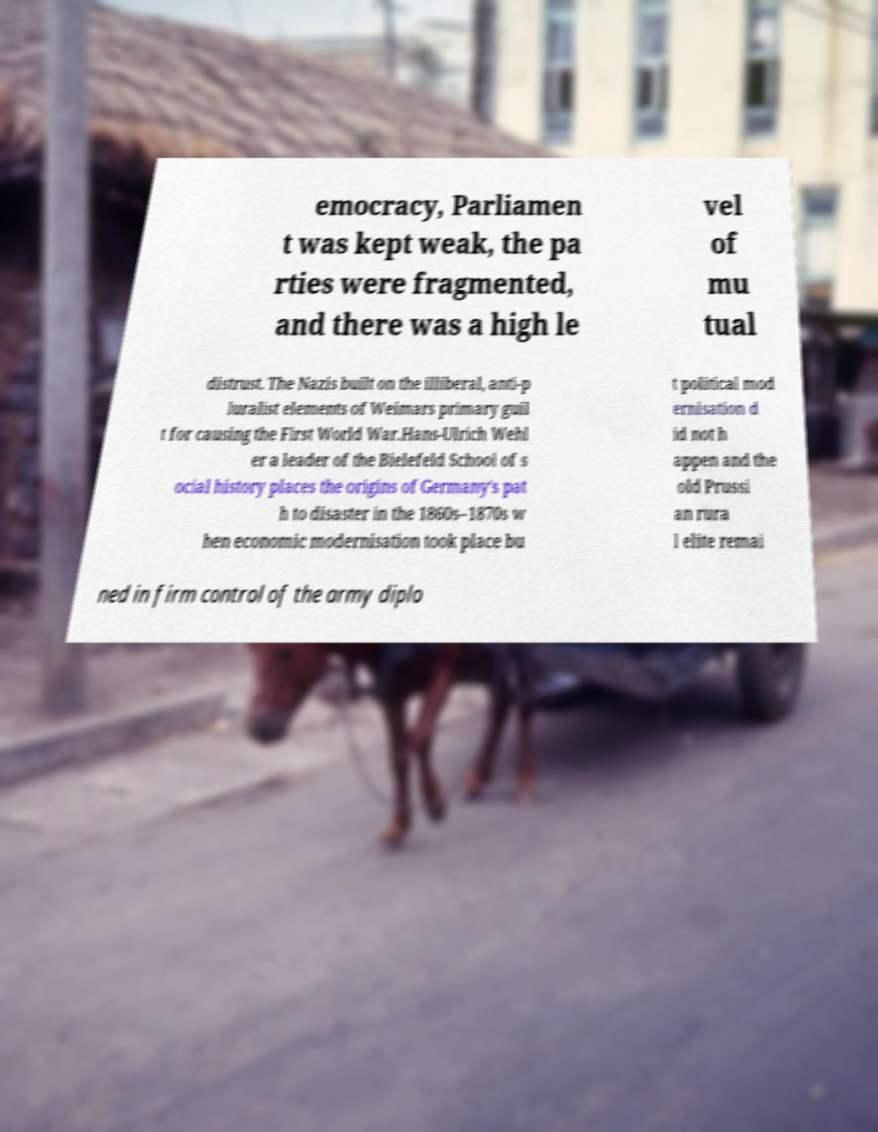For documentation purposes, I need the text within this image transcribed. Could you provide that? emocracy, Parliamen t was kept weak, the pa rties were fragmented, and there was a high le vel of mu tual distrust. The Nazis built on the illiberal, anti-p luralist elements of Weimars primary guil t for causing the First World War.Hans-Ulrich Wehl er a leader of the Bielefeld School of s ocial history places the origins of Germany's pat h to disaster in the 1860s–1870s w hen economic modernisation took place bu t political mod ernisation d id not h appen and the old Prussi an rura l elite remai ned in firm control of the army diplo 